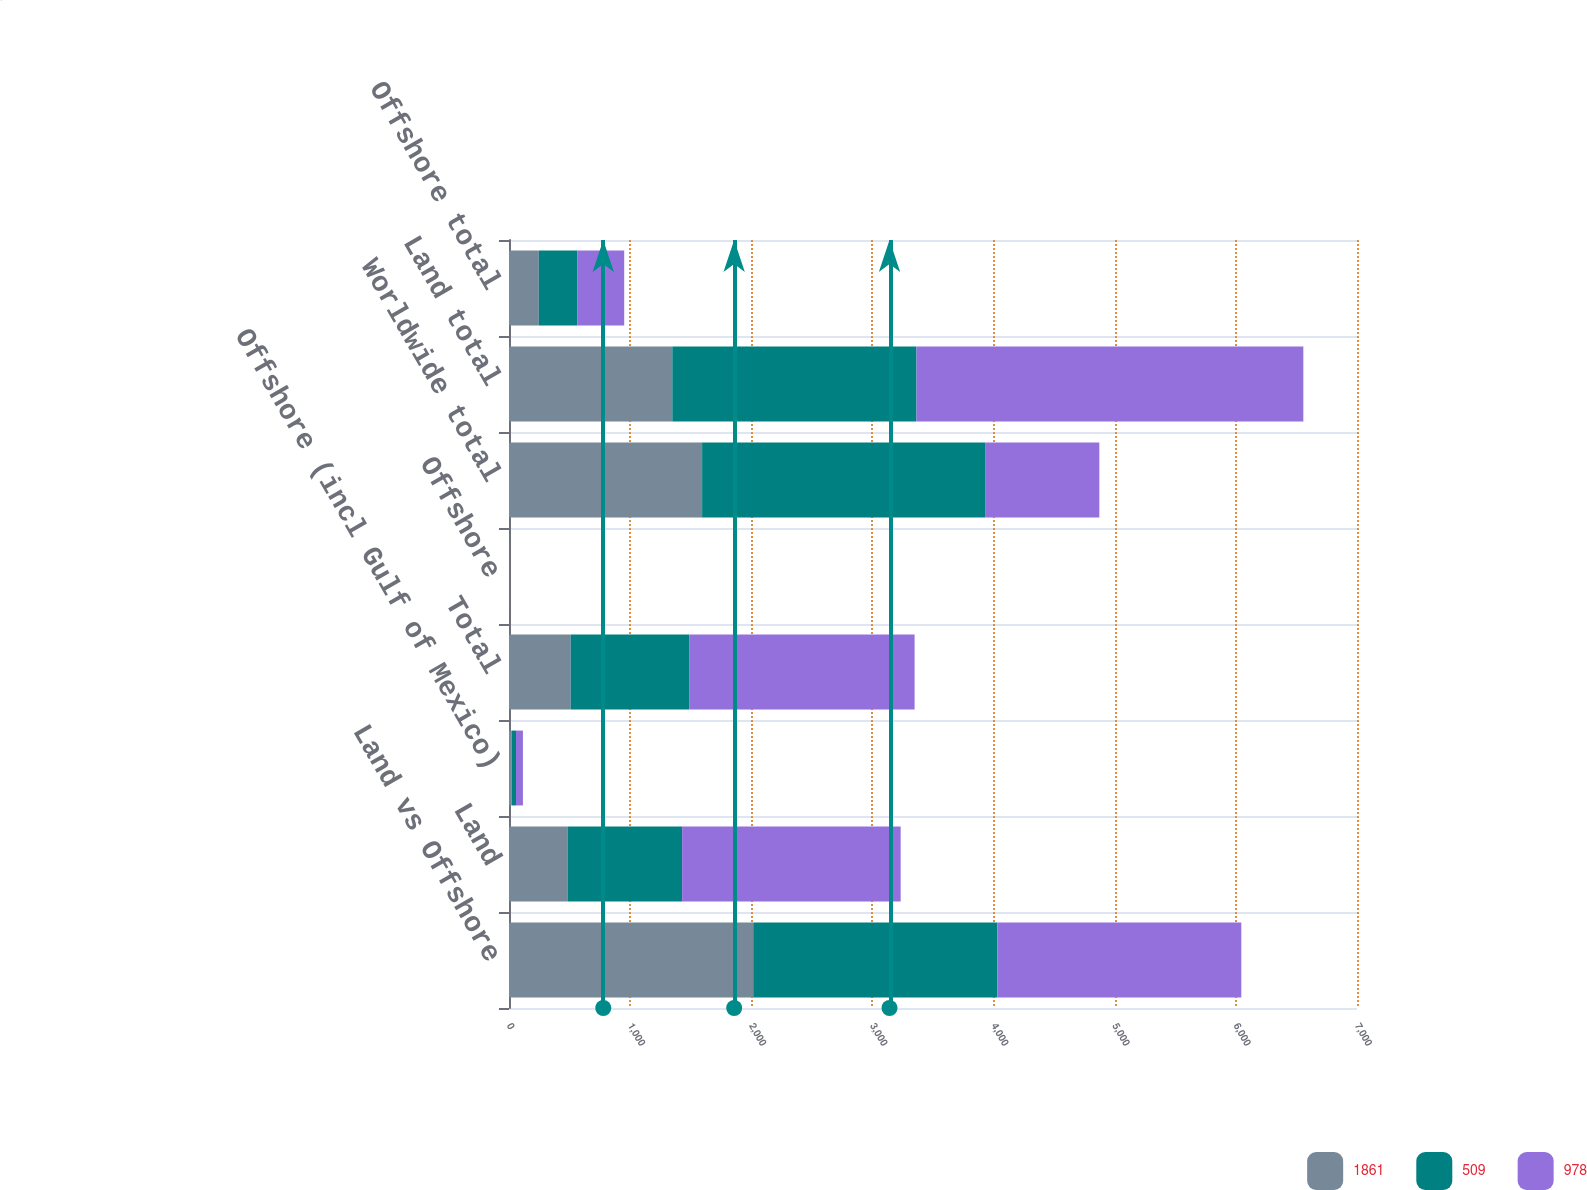Convert chart to OTSL. <chart><loc_0><loc_0><loc_500><loc_500><stacked_bar_chart><ecel><fcel>Land vs Offshore<fcel>Land<fcel>Offshore (incl Gulf of Mexico)<fcel>Total<fcel>Offshore<fcel>Worldwide total<fcel>Land total<fcel>Offshore total<nl><fcel>1861<fcel>2016<fcel>486<fcel>23<fcel>509<fcel>2<fcel>1594<fcel>1348<fcel>246<nl><fcel>509<fcel>2015<fcel>943<fcel>35<fcel>978<fcel>2<fcel>2336<fcel>2016<fcel>320<nl><fcel>978<fcel>2014<fcel>1804<fcel>57<fcel>1861<fcel>2<fcel>943<fcel>3193<fcel>385<nl></chart> 